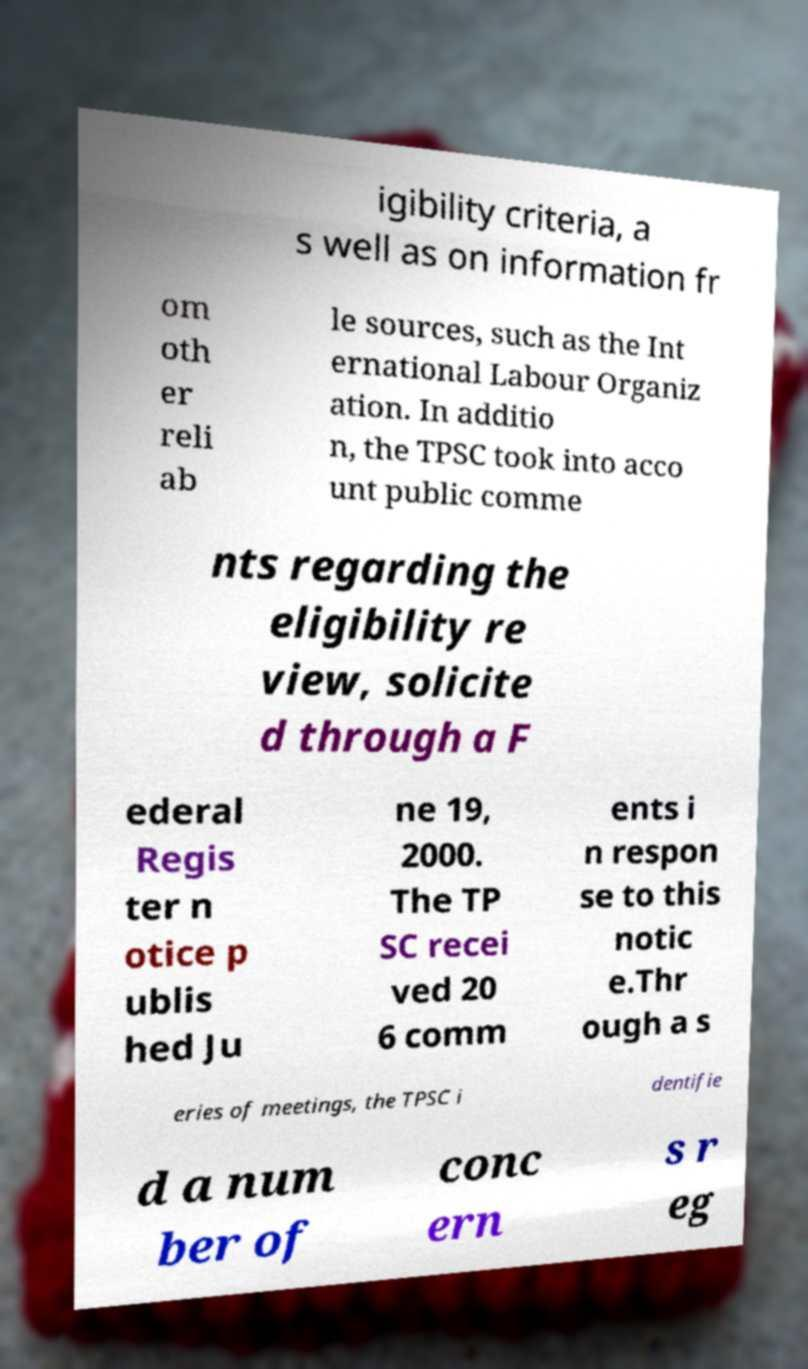Can you read and provide the text displayed in the image?This photo seems to have some interesting text. Can you extract and type it out for me? igibility criteria, a s well as on information fr om oth er reli ab le sources, such as the Int ernational Labour Organiz ation. In additio n, the TPSC took into acco unt public comme nts regarding the eligibility re view, solicite d through a F ederal Regis ter n otice p ublis hed Ju ne 19, 2000. The TP SC recei ved 20 6 comm ents i n respon se to this notic e.Thr ough a s eries of meetings, the TPSC i dentifie d a num ber of conc ern s r eg 